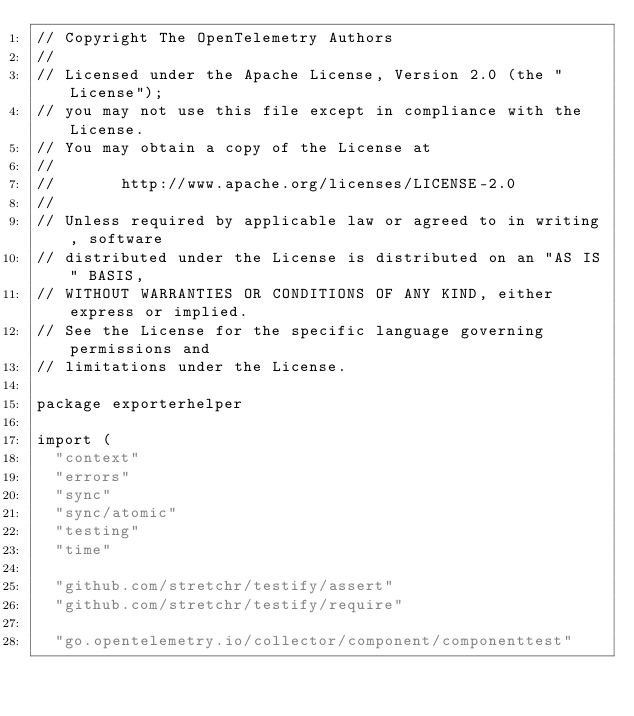Convert code to text. <code><loc_0><loc_0><loc_500><loc_500><_Go_>// Copyright The OpenTelemetry Authors
//
// Licensed under the Apache License, Version 2.0 (the "License");
// you may not use this file except in compliance with the License.
// You may obtain a copy of the License at
//
//       http://www.apache.org/licenses/LICENSE-2.0
//
// Unless required by applicable law or agreed to in writing, software
// distributed under the License is distributed on an "AS IS" BASIS,
// WITHOUT WARRANTIES OR CONDITIONS OF ANY KIND, either express or implied.
// See the License for the specific language governing permissions and
// limitations under the License.

package exporterhelper

import (
	"context"
	"errors"
	"sync"
	"sync/atomic"
	"testing"
	"time"

	"github.com/stretchr/testify/assert"
	"github.com/stretchr/testify/require"

	"go.opentelemetry.io/collector/component/componenttest"</code> 